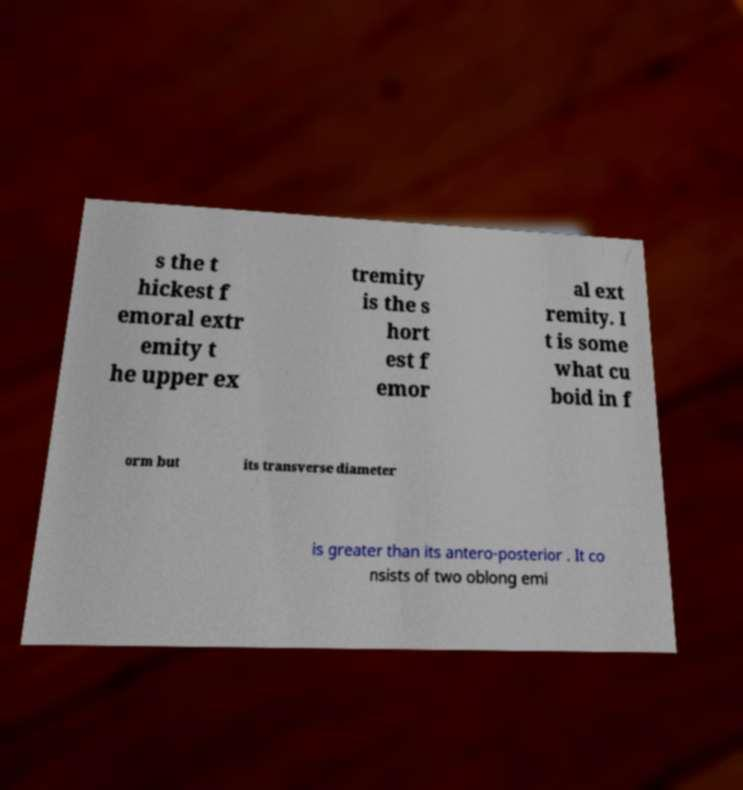Please identify and transcribe the text found in this image. s the t hickest f emoral extr emity t he upper ex tremity is the s hort est f emor al ext remity. I t is some what cu boid in f orm but its transverse diameter is greater than its antero-posterior . It co nsists of two oblong emi 